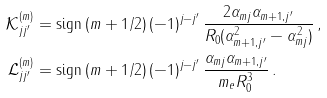<formula> <loc_0><loc_0><loc_500><loc_500>\mathcal { K } _ { j j ^ { \prime } } ^ { ( m ) } & = \text {sign} \, ( m + 1 / 2 ) \, ( - 1 ) ^ { j - j ^ { \prime } } \, \frac { 2 \alpha _ { m j } \alpha _ { m + 1 , j ^ { \prime } } } { R _ { 0 } ( \alpha _ { m + 1 , j ^ { \prime } } ^ { 2 } - \alpha _ { m j } ^ { 2 } ) } \, , \\ \mathcal { L } _ { j j ^ { \prime } } ^ { ( m ) } & = \text {sign} \, ( m + 1 / 2 ) \, ( - 1 ) ^ { j - j ^ { \prime } } \, \frac { \alpha _ { m j } \alpha _ { m + 1 , j ^ { \prime } } } { m _ { e } R _ { 0 } ^ { 3 } } \, .</formula> 